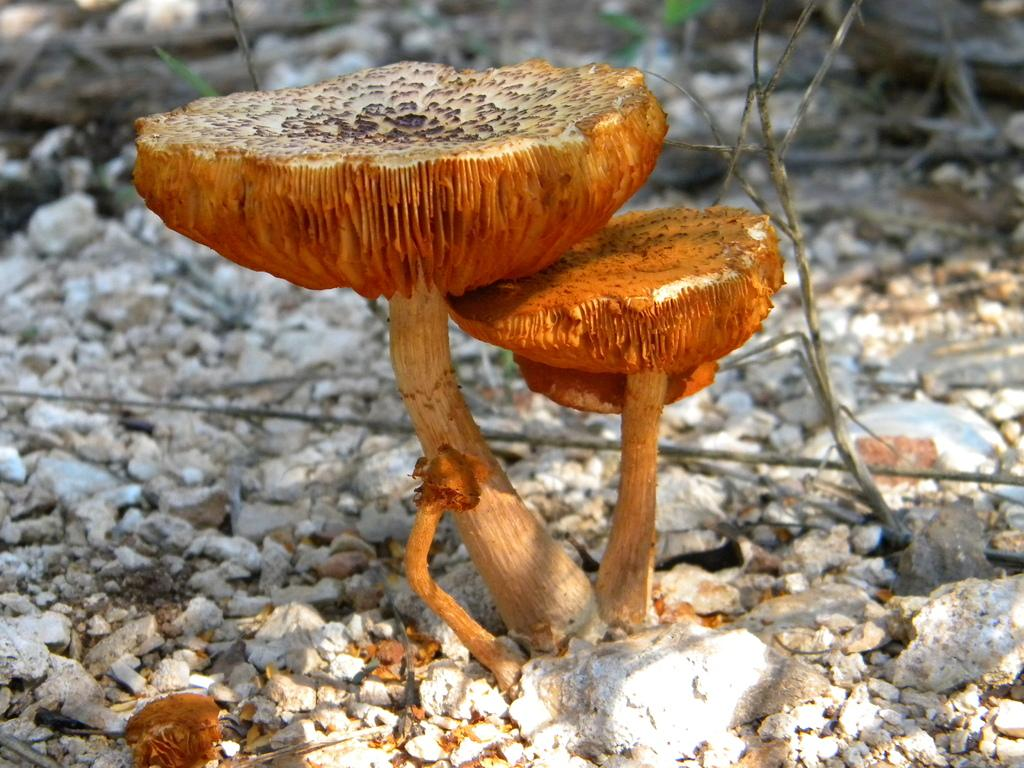Where was the image taken? The image was clicked outside. What is the main subject in the center of the image? There is a mushroom plant in the center of the image. What type of ground cover can be seen in the background of the image? There are gravels and stones in the background of the image. What type of bed can be seen in the image? There is no bed present in the image; it features a mushroom plant and background elements of gravels and stones. What songs are being played in the background of the image? There is no audio or indication of songs being played in the image; it is a still photograph. 